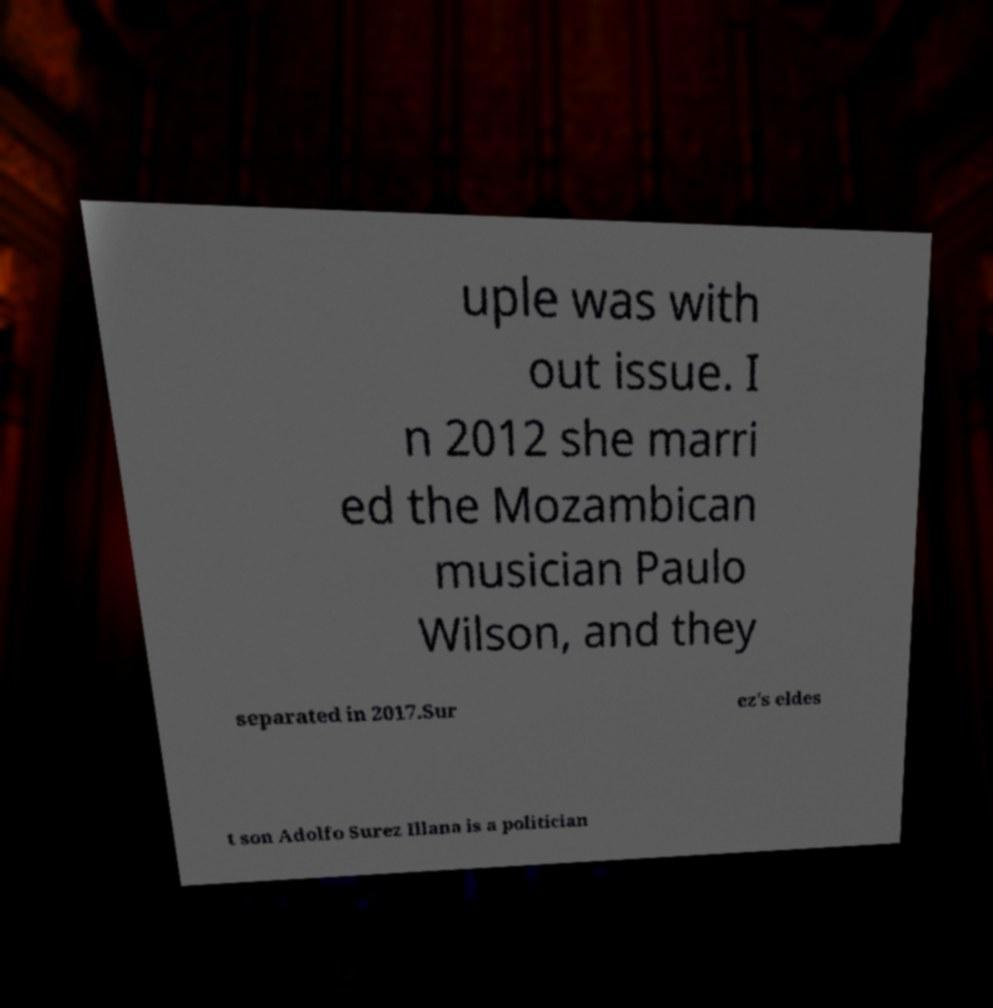Can you read and provide the text displayed in the image?This photo seems to have some interesting text. Can you extract and type it out for me? uple was with out issue. I n 2012 she marri ed the Mozambican musician Paulo Wilson, and they separated in 2017.Sur ez's eldes t son Adolfo Surez Illana is a politician 